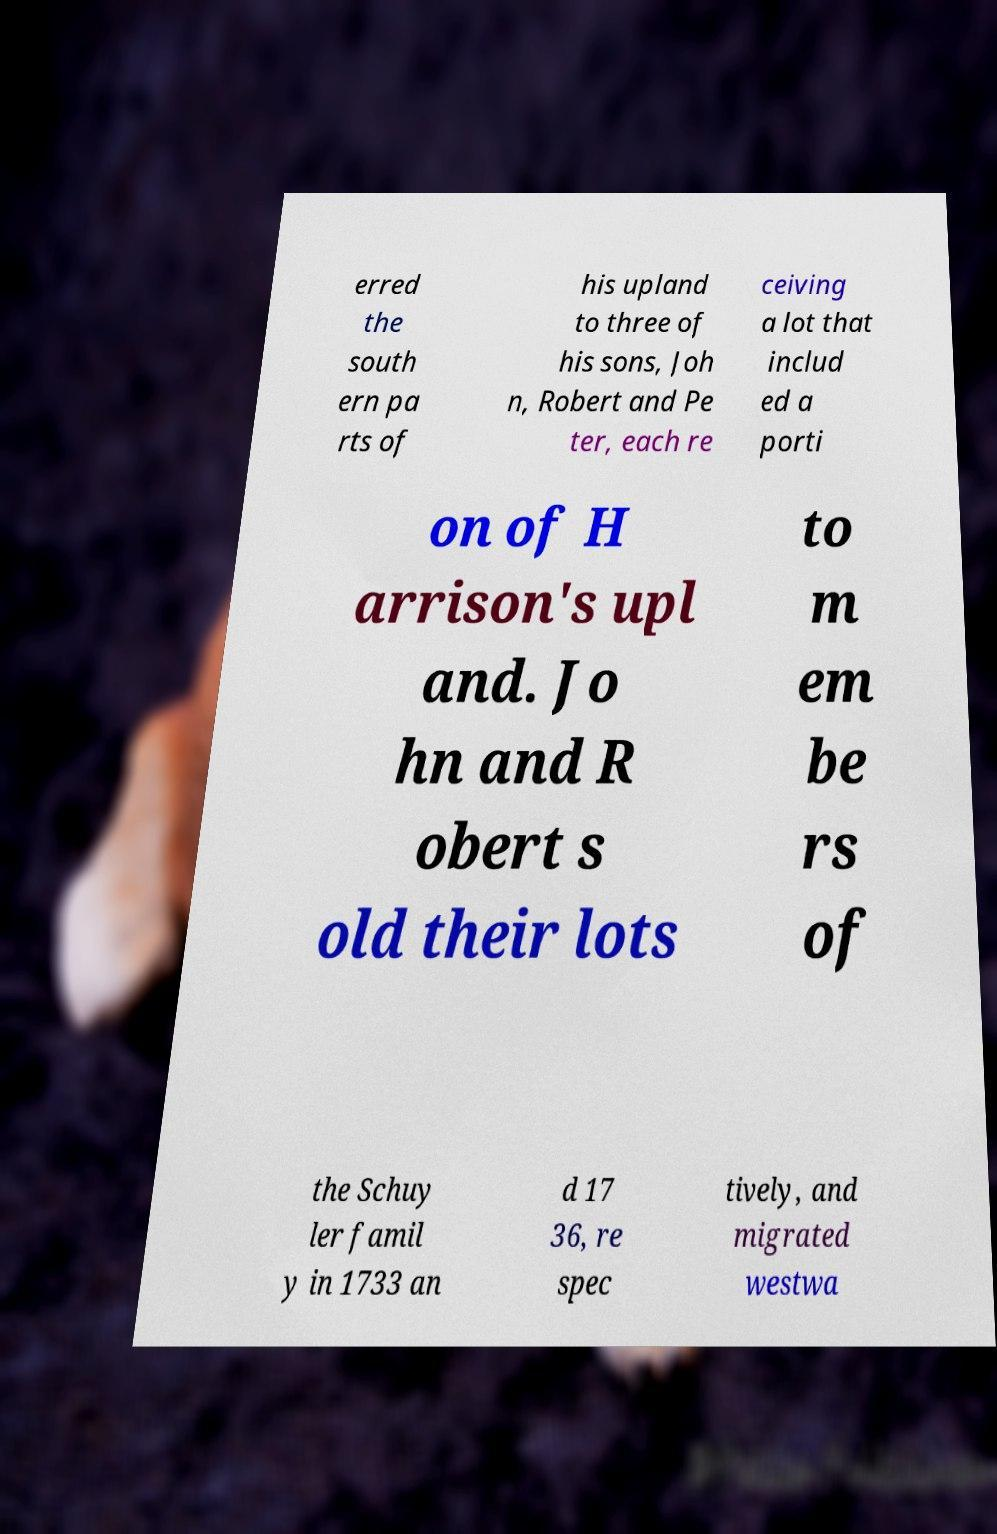I need the written content from this picture converted into text. Can you do that? erred the south ern pa rts of his upland to three of his sons, Joh n, Robert and Pe ter, each re ceiving a lot that includ ed a porti on of H arrison's upl and. Jo hn and R obert s old their lots to m em be rs of the Schuy ler famil y in 1733 an d 17 36, re spec tively, and migrated westwa 